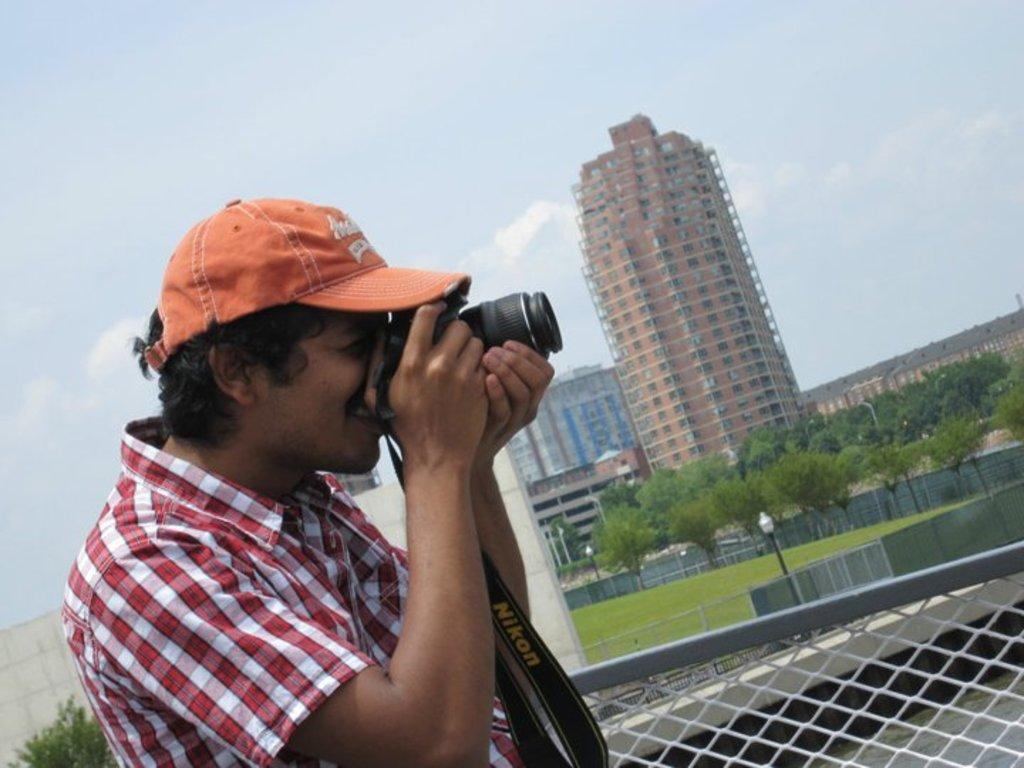What can be seen in the image? There is a person in the image. Can you describe the person's appearance? The person is wearing an orange cap. What is the person holding in his hand? The person is holding a camera in his hand. What can be seen in the background of the image? There is fencing, trees, and buildings visible in the background. Is the person's aunt in the image holding a pet? There is no aunt or pet present in the image. 